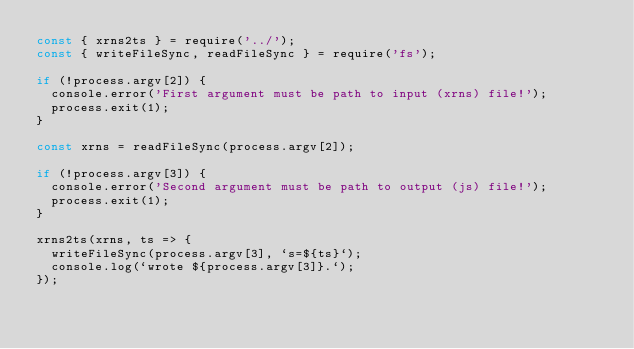<code> <loc_0><loc_0><loc_500><loc_500><_JavaScript_>const { xrns2ts } = require('../');
const { writeFileSync, readFileSync } = require('fs');

if (!process.argv[2]) {
  console.error('First argument must be path to input (xrns) file!');
  process.exit(1);
}

const xrns = readFileSync(process.argv[2]);

if (!process.argv[3]) {
  console.error('Second argument must be path to output (js) file!');
  process.exit(1);
}

xrns2ts(xrns, ts => {
  writeFileSync(process.argv[3], `s=${ts}`);
  console.log(`wrote ${process.argv[3]}.`);
});
</code> 